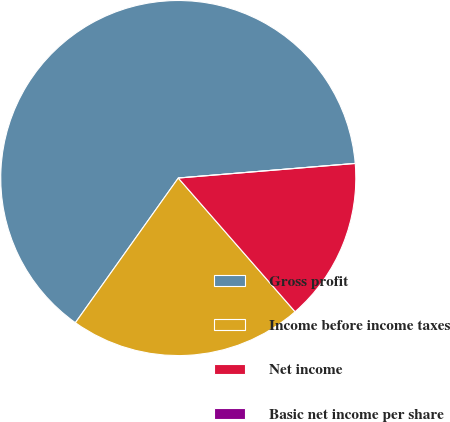Convert chart. <chart><loc_0><loc_0><loc_500><loc_500><pie_chart><fcel>Gross profit<fcel>Income before income taxes<fcel>Net income<fcel>Basic net income per share<nl><fcel>63.85%<fcel>21.27%<fcel>14.88%<fcel>0.0%<nl></chart> 